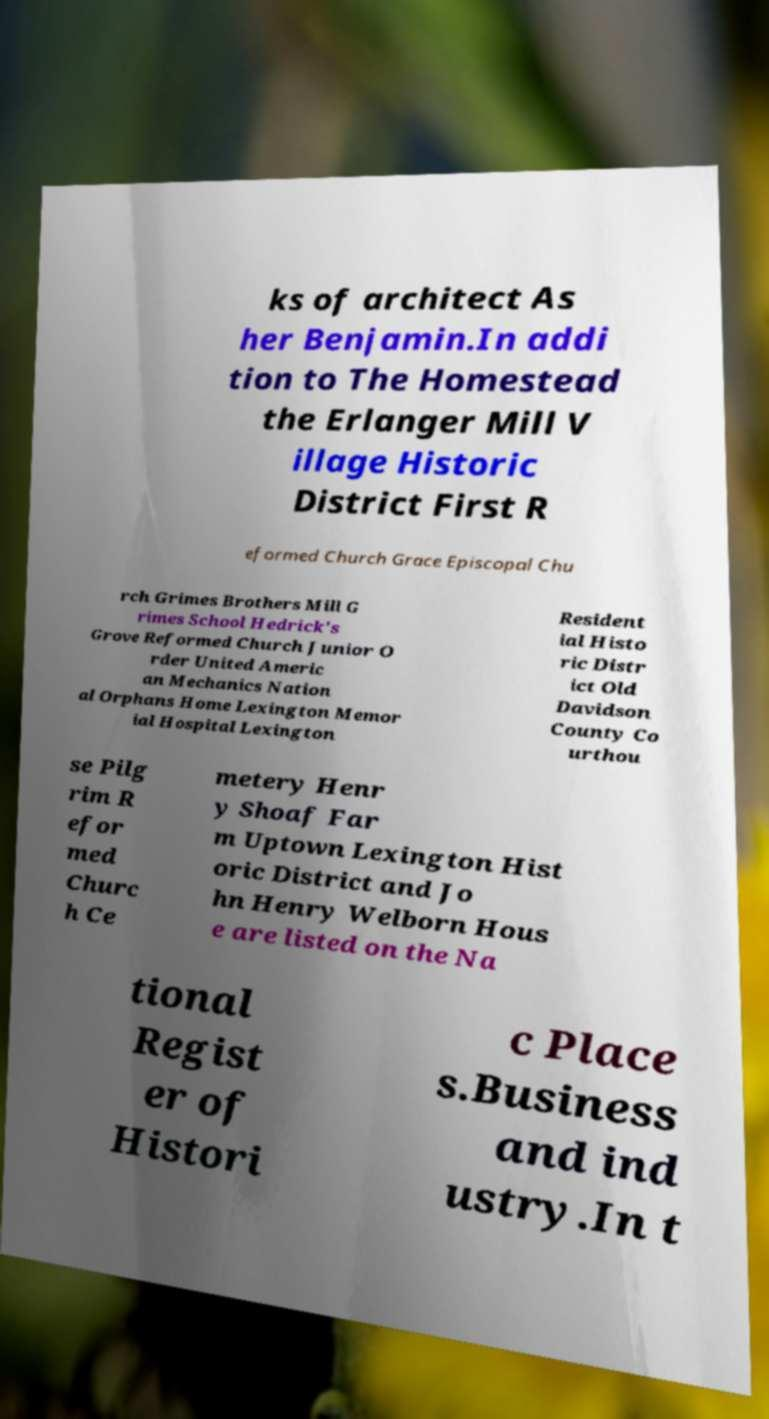Can you accurately transcribe the text from the provided image for me? ks of architect As her Benjamin.In addi tion to The Homestead the Erlanger Mill V illage Historic District First R eformed Church Grace Episcopal Chu rch Grimes Brothers Mill G rimes School Hedrick's Grove Reformed Church Junior O rder United Americ an Mechanics Nation al Orphans Home Lexington Memor ial Hospital Lexington Resident ial Histo ric Distr ict Old Davidson County Co urthou se Pilg rim R efor med Churc h Ce metery Henr y Shoaf Far m Uptown Lexington Hist oric District and Jo hn Henry Welborn Hous e are listed on the Na tional Regist er of Histori c Place s.Business and ind ustry.In t 